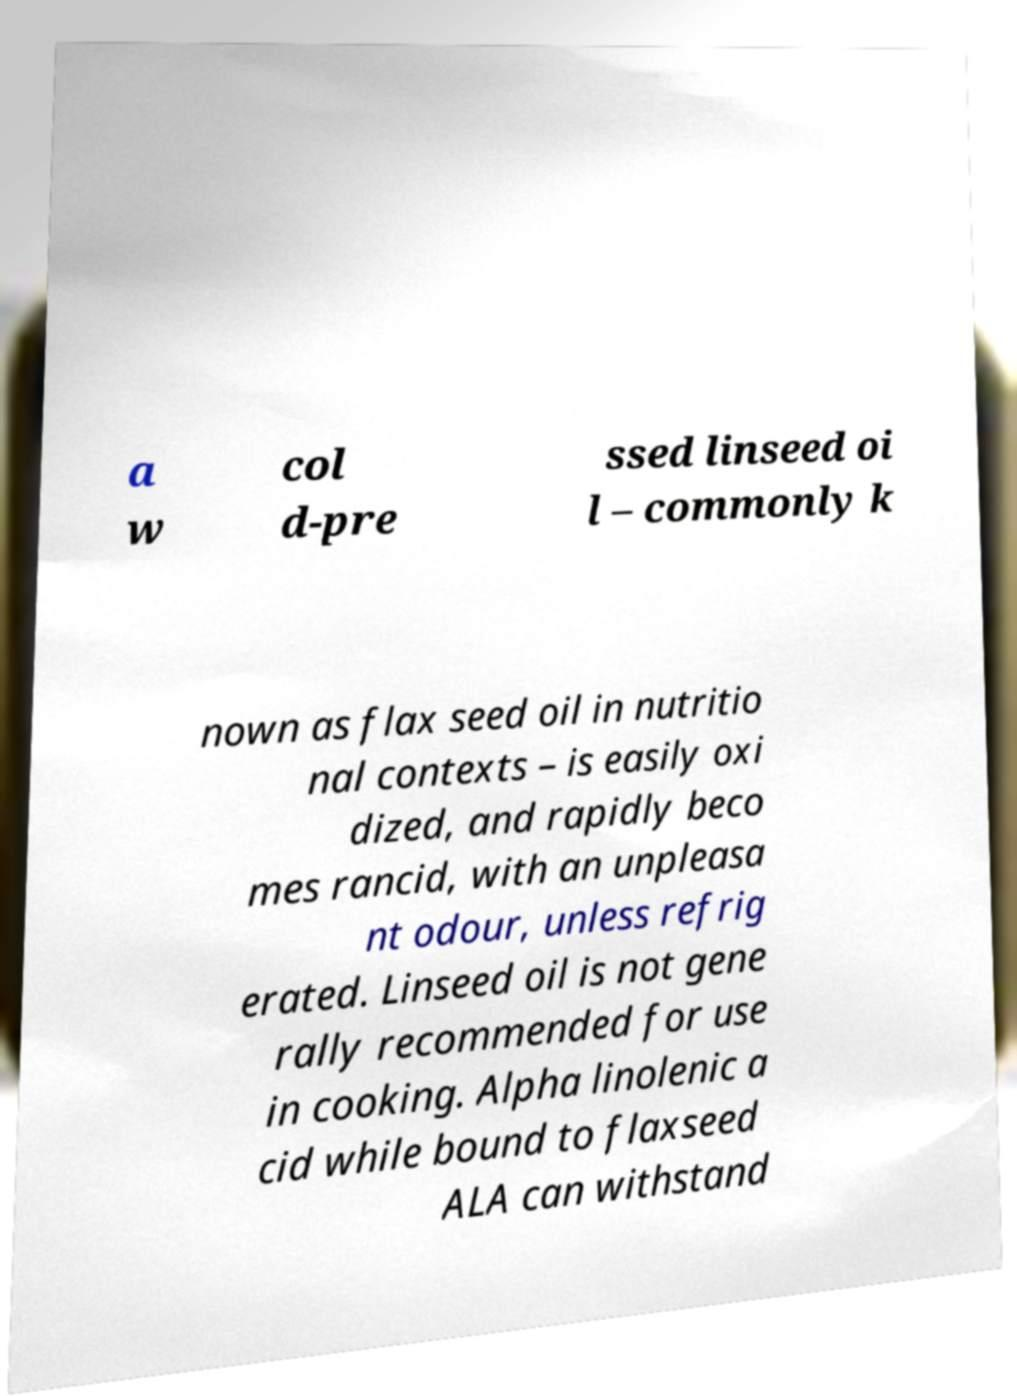Can you accurately transcribe the text from the provided image for me? a w col d-pre ssed linseed oi l – commonly k nown as flax seed oil in nutritio nal contexts – is easily oxi dized, and rapidly beco mes rancid, with an unpleasa nt odour, unless refrig erated. Linseed oil is not gene rally recommended for use in cooking. Alpha linolenic a cid while bound to flaxseed ALA can withstand 